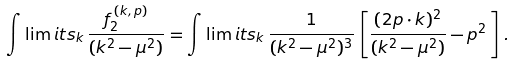Convert formula to latex. <formula><loc_0><loc_0><loc_500><loc_500>\int \lim i t s _ { k } \, \frac { f _ { 2 } ^ { \, ( k , \, p ) } } { ( k ^ { 2 } - \mu ^ { 2 } ) } = \int \lim i t s _ { k } \, \frac { 1 } { ( k ^ { 2 } - \mu ^ { 2 } ) ^ { 3 } } \, \left [ \frac { ( 2 p \cdot k ) ^ { 2 } } { ( k ^ { 2 } - \mu ^ { 2 } ) } - p ^ { 2 } \, \right ] \, .</formula> 